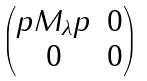<formula> <loc_0><loc_0><loc_500><loc_500>\begin{pmatrix} p M _ { \lambda } p & 0 \\ 0 & 0 \end{pmatrix}</formula> 